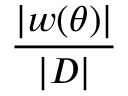<formula> <loc_0><loc_0><loc_500><loc_500>\frac { | w ( \theta ) | } { | D | }</formula> 